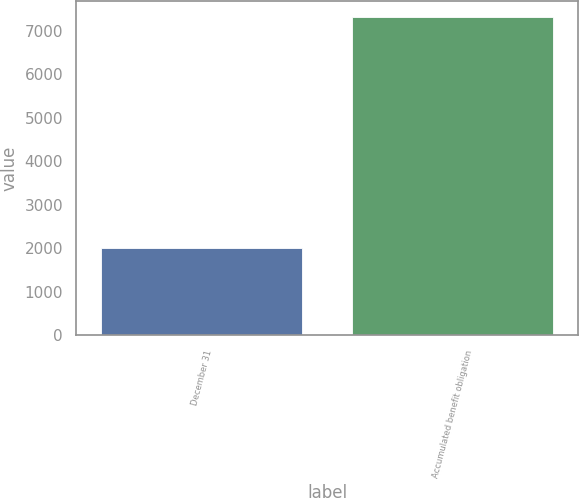Convert chart to OTSL. <chart><loc_0><loc_0><loc_500><loc_500><bar_chart><fcel>December 31<fcel>Accumulated benefit obligation<nl><fcel>2013<fcel>7317<nl></chart> 